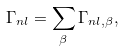<formula> <loc_0><loc_0><loc_500><loc_500>\Gamma _ { n l } = \sum _ { \beta } \Gamma _ { n l , \beta } ,</formula> 